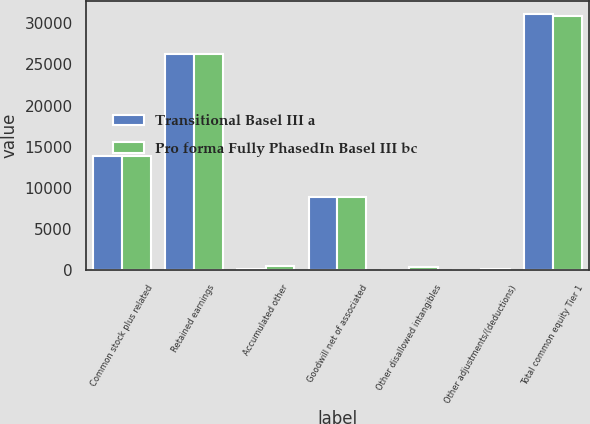Convert chart. <chart><loc_0><loc_0><loc_500><loc_500><stacked_bar_chart><ecel><fcel>Common stock plus related<fcel>Retained earnings<fcel>Accumulated other<fcel>Goodwill net of associated<fcel>Other disallowed intangibles<fcel>Other adjustments/(deductions)<fcel>Total common equity Tier 1<nl><fcel>Transitional Basel III a<fcel>13903<fcel>26200<fcel>104<fcel>8855<fcel>84<fcel>63<fcel>31141<nl><fcel>Pro forma Fully PhasedIn Basel III bc<fcel>13903<fcel>26200<fcel>520<fcel>8855<fcel>421<fcel>121<fcel>30907<nl></chart> 